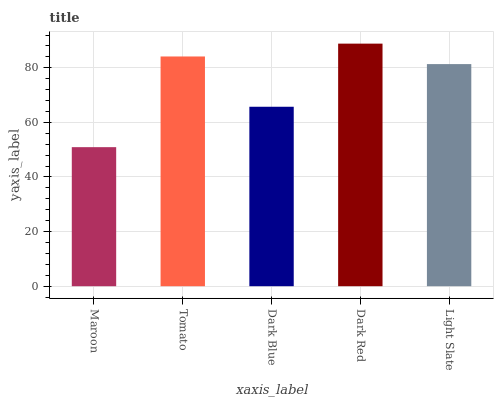Is Maroon the minimum?
Answer yes or no. Yes. Is Dark Red the maximum?
Answer yes or no. Yes. Is Tomato the minimum?
Answer yes or no. No. Is Tomato the maximum?
Answer yes or no. No. Is Tomato greater than Maroon?
Answer yes or no. Yes. Is Maroon less than Tomato?
Answer yes or no. Yes. Is Maroon greater than Tomato?
Answer yes or no. No. Is Tomato less than Maroon?
Answer yes or no. No. Is Light Slate the high median?
Answer yes or no. Yes. Is Light Slate the low median?
Answer yes or no. Yes. Is Dark Red the high median?
Answer yes or no. No. Is Tomato the low median?
Answer yes or no. No. 